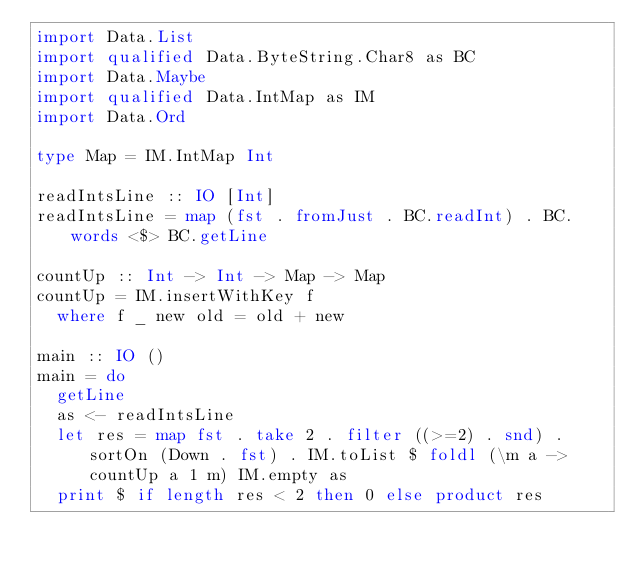Convert code to text. <code><loc_0><loc_0><loc_500><loc_500><_Haskell_>import Data.List
import qualified Data.ByteString.Char8 as BC
import Data.Maybe
import qualified Data.IntMap as IM
import Data.Ord

type Map = IM.IntMap Int

readIntsLine :: IO [Int]
readIntsLine = map (fst . fromJust . BC.readInt) . BC.words <$> BC.getLine

countUp :: Int -> Int -> Map -> Map
countUp = IM.insertWithKey f
  where f _ new old = old + new

main :: IO ()
main = do
  getLine
  as <- readIntsLine
  let res = map fst . take 2 . filter ((>=2) . snd) . sortOn (Down . fst) . IM.toList $ foldl (\m a -> countUp a 1 m) IM.empty as
  print $ if length res < 2 then 0 else product res</code> 